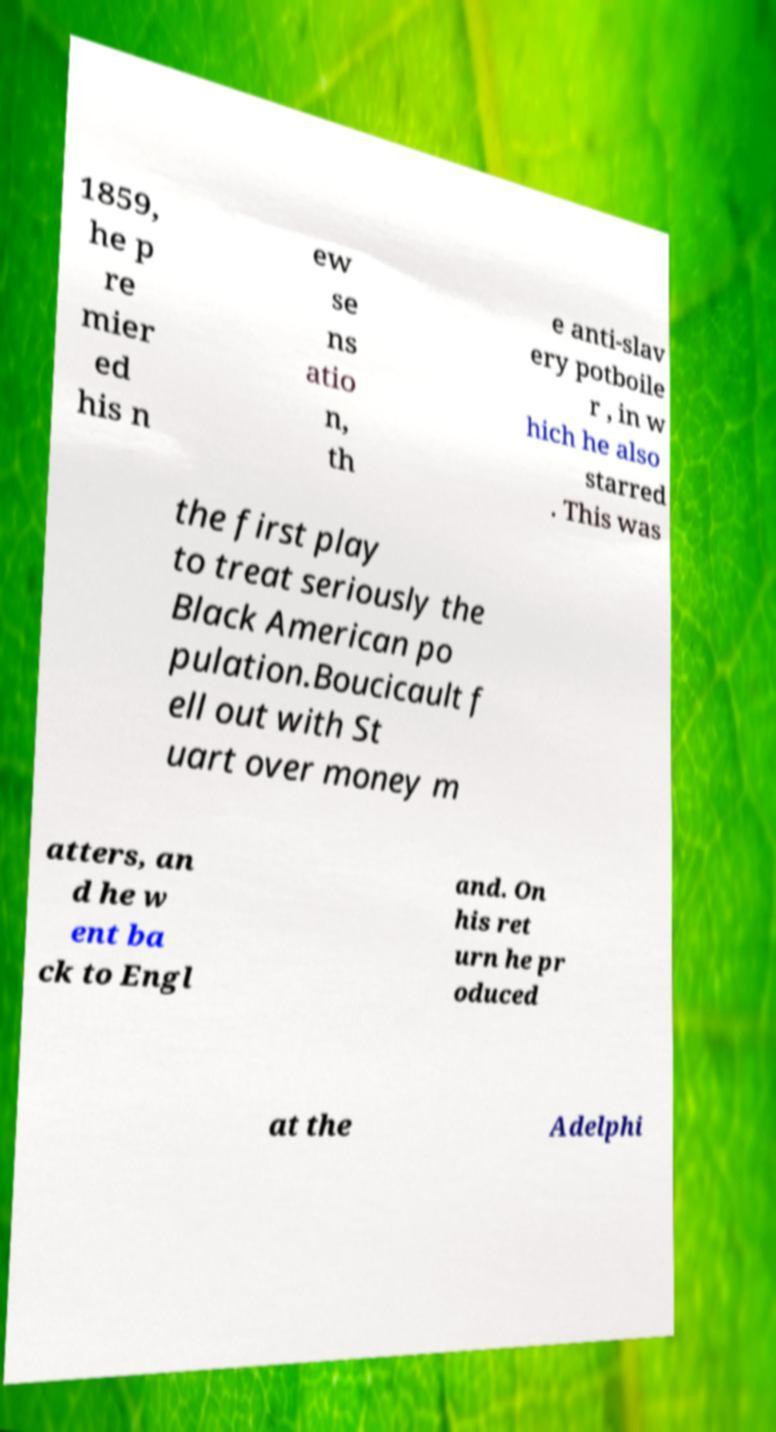Could you extract and type out the text from this image? 1859, he p re mier ed his n ew se ns atio n, th e anti-slav ery potboile r , in w hich he also starred . This was the first play to treat seriously the Black American po pulation.Boucicault f ell out with St uart over money m atters, an d he w ent ba ck to Engl and. On his ret urn he pr oduced at the Adelphi 